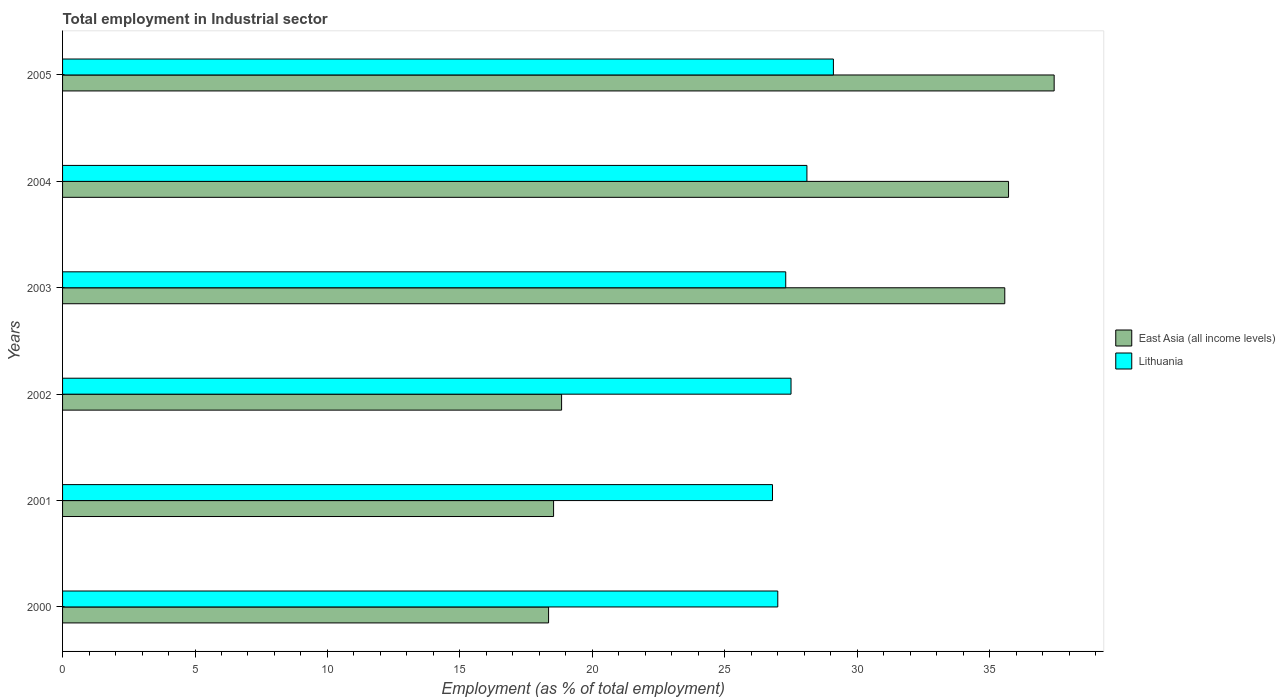How many different coloured bars are there?
Your answer should be compact. 2. How many bars are there on the 1st tick from the top?
Provide a succinct answer. 2. How many bars are there on the 2nd tick from the bottom?
Keep it short and to the point. 2. What is the label of the 2nd group of bars from the top?
Your answer should be compact. 2004. In how many cases, is the number of bars for a given year not equal to the number of legend labels?
Your response must be concise. 0. What is the employment in industrial sector in East Asia (all income levels) in 2000?
Your response must be concise. 18.35. Across all years, what is the maximum employment in industrial sector in East Asia (all income levels)?
Keep it short and to the point. 37.43. Across all years, what is the minimum employment in industrial sector in East Asia (all income levels)?
Your answer should be very brief. 18.35. In which year was the employment in industrial sector in Lithuania maximum?
Make the answer very short. 2005. In which year was the employment in industrial sector in Lithuania minimum?
Your response must be concise. 2001. What is the total employment in industrial sector in Lithuania in the graph?
Your response must be concise. 165.8. What is the difference between the employment in industrial sector in Lithuania in 2004 and that in 2005?
Provide a short and direct response. -1. What is the difference between the employment in industrial sector in Lithuania in 2005 and the employment in industrial sector in East Asia (all income levels) in 2002?
Keep it short and to the point. 10.26. What is the average employment in industrial sector in East Asia (all income levels) per year?
Give a very brief answer. 27.41. In the year 2002, what is the difference between the employment in industrial sector in East Asia (all income levels) and employment in industrial sector in Lithuania?
Your answer should be compact. -8.66. In how many years, is the employment in industrial sector in Lithuania greater than 35 %?
Your answer should be very brief. 0. What is the ratio of the employment in industrial sector in East Asia (all income levels) in 2002 to that in 2005?
Your response must be concise. 0.5. Is the employment in industrial sector in Lithuania in 2000 less than that in 2001?
Make the answer very short. No. What is the difference between the highest and the second highest employment in industrial sector in East Asia (all income levels)?
Make the answer very short. 1.72. What is the difference between the highest and the lowest employment in industrial sector in Lithuania?
Offer a very short reply. 2.3. In how many years, is the employment in industrial sector in East Asia (all income levels) greater than the average employment in industrial sector in East Asia (all income levels) taken over all years?
Provide a succinct answer. 3. Is the sum of the employment in industrial sector in Lithuania in 2000 and 2003 greater than the maximum employment in industrial sector in East Asia (all income levels) across all years?
Ensure brevity in your answer.  Yes. What does the 2nd bar from the top in 2005 represents?
Your response must be concise. East Asia (all income levels). What does the 2nd bar from the bottom in 2004 represents?
Make the answer very short. Lithuania. How many years are there in the graph?
Provide a short and direct response. 6. Where does the legend appear in the graph?
Make the answer very short. Center right. How are the legend labels stacked?
Your response must be concise. Vertical. What is the title of the graph?
Offer a terse response. Total employment in Industrial sector. What is the label or title of the X-axis?
Make the answer very short. Employment (as % of total employment). What is the Employment (as % of total employment) in East Asia (all income levels) in 2000?
Ensure brevity in your answer.  18.35. What is the Employment (as % of total employment) in East Asia (all income levels) in 2001?
Your answer should be compact. 18.54. What is the Employment (as % of total employment) in Lithuania in 2001?
Your response must be concise. 26.8. What is the Employment (as % of total employment) in East Asia (all income levels) in 2002?
Offer a very short reply. 18.84. What is the Employment (as % of total employment) in East Asia (all income levels) in 2003?
Offer a very short reply. 35.57. What is the Employment (as % of total employment) of Lithuania in 2003?
Offer a very short reply. 27.3. What is the Employment (as % of total employment) of East Asia (all income levels) in 2004?
Ensure brevity in your answer.  35.71. What is the Employment (as % of total employment) of Lithuania in 2004?
Give a very brief answer. 28.1. What is the Employment (as % of total employment) of East Asia (all income levels) in 2005?
Your answer should be very brief. 37.43. What is the Employment (as % of total employment) in Lithuania in 2005?
Offer a terse response. 29.1. Across all years, what is the maximum Employment (as % of total employment) in East Asia (all income levels)?
Your answer should be compact. 37.43. Across all years, what is the maximum Employment (as % of total employment) of Lithuania?
Offer a very short reply. 29.1. Across all years, what is the minimum Employment (as % of total employment) in East Asia (all income levels)?
Offer a terse response. 18.35. Across all years, what is the minimum Employment (as % of total employment) in Lithuania?
Your response must be concise. 26.8. What is the total Employment (as % of total employment) in East Asia (all income levels) in the graph?
Offer a terse response. 164.44. What is the total Employment (as % of total employment) in Lithuania in the graph?
Provide a short and direct response. 165.8. What is the difference between the Employment (as % of total employment) of East Asia (all income levels) in 2000 and that in 2001?
Your response must be concise. -0.19. What is the difference between the Employment (as % of total employment) of Lithuania in 2000 and that in 2001?
Keep it short and to the point. 0.2. What is the difference between the Employment (as % of total employment) in East Asia (all income levels) in 2000 and that in 2002?
Provide a short and direct response. -0.49. What is the difference between the Employment (as % of total employment) of East Asia (all income levels) in 2000 and that in 2003?
Your answer should be very brief. -17.22. What is the difference between the Employment (as % of total employment) in East Asia (all income levels) in 2000 and that in 2004?
Make the answer very short. -17.36. What is the difference between the Employment (as % of total employment) of East Asia (all income levels) in 2000 and that in 2005?
Provide a short and direct response. -19.09. What is the difference between the Employment (as % of total employment) of East Asia (all income levels) in 2001 and that in 2002?
Your answer should be compact. -0.3. What is the difference between the Employment (as % of total employment) in East Asia (all income levels) in 2001 and that in 2003?
Offer a terse response. -17.03. What is the difference between the Employment (as % of total employment) of Lithuania in 2001 and that in 2003?
Offer a very short reply. -0.5. What is the difference between the Employment (as % of total employment) in East Asia (all income levels) in 2001 and that in 2004?
Give a very brief answer. -17.18. What is the difference between the Employment (as % of total employment) in Lithuania in 2001 and that in 2004?
Ensure brevity in your answer.  -1.3. What is the difference between the Employment (as % of total employment) of East Asia (all income levels) in 2001 and that in 2005?
Offer a terse response. -18.9. What is the difference between the Employment (as % of total employment) of Lithuania in 2001 and that in 2005?
Ensure brevity in your answer.  -2.3. What is the difference between the Employment (as % of total employment) of East Asia (all income levels) in 2002 and that in 2003?
Offer a terse response. -16.73. What is the difference between the Employment (as % of total employment) in Lithuania in 2002 and that in 2003?
Provide a succinct answer. 0.2. What is the difference between the Employment (as % of total employment) of East Asia (all income levels) in 2002 and that in 2004?
Offer a very short reply. -16.87. What is the difference between the Employment (as % of total employment) in Lithuania in 2002 and that in 2004?
Give a very brief answer. -0.6. What is the difference between the Employment (as % of total employment) of East Asia (all income levels) in 2002 and that in 2005?
Offer a very short reply. -18.59. What is the difference between the Employment (as % of total employment) of East Asia (all income levels) in 2003 and that in 2004?
Offer a very short reply. -0.14. What is the difference between the Employment (as % of total employment) in Lithuania in 2003 and that in 2004?
Provide a succinct answer. -0.8. What is the difference between the Employment (as % of total employment) of East Asia (all income levels) in 2003 and that in 2005?
Your response must be concise. -1.86. What is the difference between the Employment (as % of total employment) of Lithuania in 2003 and that in 2005?
Your response must be concise. -1.8. What is the difference between the Employment (as % of total employment) in East Asia (all income levels) in 2004 and that in 2005?
Provide a short and direct response. -1.72. What is the difference between the Employment (as % of total employment) of Lithuania in 2004 and that in 2005?
Provide a short and direct response. -1. What is the difference between the Employment (as % of total employment) of East Asia (all income levels) in 2000 and the Employment (as % of total employment) of Lithuania in 2001?
Ensure brevity in your answer.  -8.45. What is the difference between the Employment (as % of total employment) of East Asia (all income levels) in 2000 and the Employment (as % of total employment) of Lithuania in 2002?
Provide a succinct answer. -9.15. What is the difference between the Employment (as % of total employment) in East Asia (all income levels) in 2000 and the Employment (as % of total employment) in Lithuania in 2003?
Your answer should be very brief. -8.95. What is the difference between the Employment (as % of total employment) in East Asia (all income levels) in 2000 and the Employment (as % of total employment) in Lithuania in 2004?
Your response must be concise. -9.75. What is the difference between the Employment (as % of total employment) in East Asia (all income levels) in 2000 and the Employment (as % of total employment) in Lithuania in 2005?
Offer a terse response. -10.75. What is the difference between the Employment (as % of total employment) in East Asia (all income levels) in 2001 and the Employment (as % of total employment) in Lithuania in 2002?
Keep it short and to the point. -8.96. What is the difference between the Employment (as % of total employment) in East Asia (all income levels) in 2001 and the Employment (as % of total employment) in Lithuania in 2003?
Give a very brief answer. -8.76. What is the difference between the Employment (as % of total employment) of East Asia (all income levels) in 2001 and the Employment (as % of total employment) of Lithuania in 2004?
Your response must be concise. -9.56. What is the difference between the Employment (as % of total employment) of East Asia (all income levels) in 2001 and the Employment (as % of total employment) of Lithuania in 2005?
Offer a very short reply. -10.56. What is the difference between the Employment (as % of total employment) in East Asia (all income levels) in 2002 and the Employment (as % of total employment) in Lithuania in 2003?
Provide a short and direct response. -8.46. What is the difference between the Employment (as % of total employment) of East Asia (all income levels) in 2002 and the Employment (as % of total employment) of Lithuania in 2004?
Keep it short and to the point. -9.26. What is the difference between the Employment (as % of total employment) in East Asia (all income levels) in 2002 and the Employment (as % of total employment) in Lithuania in 2005?
Make the answer very short. -10.26. What is the difference between the Employment (as % of total employment) in East Asia (all income levels) in 2003 and the Employment (as % of total employment) in Lithuania in 2004?
Make the answer very short. 7.47. What is the difference between the Employment (as % of total employment) in East Asia (all income levels) in 2003 and the Employment (as % of total employment) in Lithuania in 2005?
Your response must be concise. 6.47. What is the difference between the Employment (as % of total employment) in East Asia (all income levels) in 2004 and the Employment (as % of total employment) in Lithuania in 2005?
Your response must be concise. 6.61. What is the average Employment (as % of total employment) of East Asia (all income levels) per year?
Ensure brevity in your answer.  27.41. What is the average Employment (as % of total employment) in Lithuania per year?
Ensure brevity in your answer.  27.63. In the year 2000, what is the difference between the Employment (as % of total employment) in East Asia (all income levels) and Employment (as % of total employment) in Lithuania?
Offer a very short reply. -8.65. In the year 2001, what is the difference between the Employment (as % of total employment) in East Asia (all income levels) and Employment (as % of total employment) in Lithuania?
Offer a terse response. -8.26. In the year 2002, what is the difference between the Employment (as % of total employment) of East Asia (all income levels) and Employment (as % of total employment) of Lithuania?
Your answer should be compact. -8.66. In the year 2003, what is the difference between the Employment (as % of total employment) in East Asia (all income levels) and Employment (as % of total employment) in Lithuania?
Provide a short and direct response. 8.27. In the year 2004, what is the difference between the Employment (as % of total employment) of East Asia (all income levels) and Employment (as % of total employment) of Lithuania?
Your response must be concise. 7.61. In the year 2005, what is the difference between the Employment (as % of total employment) of East Asia (all income levels) and Employment (as % of total employment) of Lithuania?
Give a very brief answer. 8.33. What is the ratio of the Employment (as % of total employment) of Lithuania in 2000 to that in 2001?
Make the answer very short. 1.01. What is the ratio of the Employment (as % of total employment) in East Asia (all income levels) in 2000 to that in 2002?
Give a very brief answer. 0.97. What is the ratio of the Employment (as % of total employment) in Lithuania in 2000 to that in 2002?
Provide a short and direct response. 0.98. What is the ratio of the Employment (as % of total employment) of East Asia (all income levels) in 2000 to that in 2003?
Give a very brief answer. 0.52. What is the ratio of the Employment (as % of total employment) in East Asia (all income levels) in 2000 to that in 2004?
Make the answer very short. 0.51. What is the ratio of the Employment (as % of total employment) of Lithuania in 2000 to that in 2004?
Your answer should be compact. 0.96. What is the ratio of the Employment (as % of total employment) in East Asia (all income levels) in 2000 to that in 2005?
Your answer should be compact. 0.49. What is the ratio of the Employment (as % of total employment) of Lithuania in 2000 to that in 2005?
Your answer should be very brief. 0.93. What is the ratio of the Employment (as % of total employment) of East Asia (all income levels) in 2001 to that in 2002?
Keep it short and to the point. 0.98. What is the ratio of the Employment (as % of total employment) in Lithuania in 2001 to that in 2002?
Offer a very short reply. 0.97. What is the ratio of the Employment (as % of total employment) of East Asia (all income levels) in 2001 to that in 2003?
Your answer should be compact. 0.52. What is the ratio of the Employment (as % of total employment) of Lithuania in 2001 to that in 2003?
Offer a terse response. 0.98. What is the ratio of the Employment (as % of total employment) of East Asia (all income levels) in 2001 to that in 2004?
Offer a terse response. 0.52. What is the ratio of the Employment (as % of total employment) of Lithuania in 2001 to that in 2004?
Your response must be concise. 0.95. What is the ratio of the Employment (as % of total employment) of East Asia (all income levels) in 2001 to that in 2005?
Ensure brevity in your answer.  0.5. What is the ratio of the Employment (as % of total employment) of Lithuania in 2001 to that in 2005?
Ensure brevity in your answer.  0.92. What is the ratio of the Employment (as % of total employment) of East Asia (all income levels) in 2002 to that in 2003?
Give a very brief answer. 0.53. What is the ratio of the Employment (as % of total employment) in Lithuania in 2002 to that in 2003?
Your answer should be compact. 1.01. What is the ratio of the Employment (as % of total employment) in East Asia (all income levels) in 2002 to that in 2004?
Provide a succinct answer. 0.53. What is the ratio of the Employment (as % of total employment) of Lithuania in 2002 to that in 2004?
Provide a short and direct response. 0.98. What is the ratio of the Employment (as % of total employment) of East Asia (all income levels) in 2002 to that in 2005?
Offer a terse response. 0.5. What is the ratio of the Employment (as % of total employment) of Lithuania in 2002 to that in 2005?
Your answer should be very brief. 0.94. What is the ratio of the Employment (as % of total employment) in East Asia (all income levels) in 2003 to that in 2004?
Offer a very short reply. 1. What is the ratio of the Employment (as % of total employment) in Lithuania in 2003 to that in 2004?
Your answer should be very brief. 0.97. What is the ratio of the Employment (as % of total employment) in East Asia (all income levels) in 2003 to that in 2005?
Make the answer very short. 0.95. What is the ratio of the Employment (as % of total employment) of Lithuania in 2003 to that in 2005?
Give a very brief answer. 0.94. What is the ratio of the Employment (as % of total employment) in East Asia (all income levels) in 2004 to that in 2005?
Give a very brief answer. 0.95. What is the ratio of the Employment (as % of total employment) in Lithuania in 2004 to that in 2005?
Provide a short and direct response. 0.97. What is the difference between the highest and the second highest Employment (as % of total employment) of East Asia (all income levels)?
Your response must be concise. 1.72. What is the difference between the highest and the second highest Employment (as % of total employment) in Lithuania?
Provide a short and direct response. 1. What is the difference between the highest and the lowest Employment (as % of total employment) in East Asia (all income levels)?
Make the answer very short. 19.09. What is the difference between the highest and the lowest Employment (as % of total employment) in Lithuania?
Offer a very short reply. 2.3. 